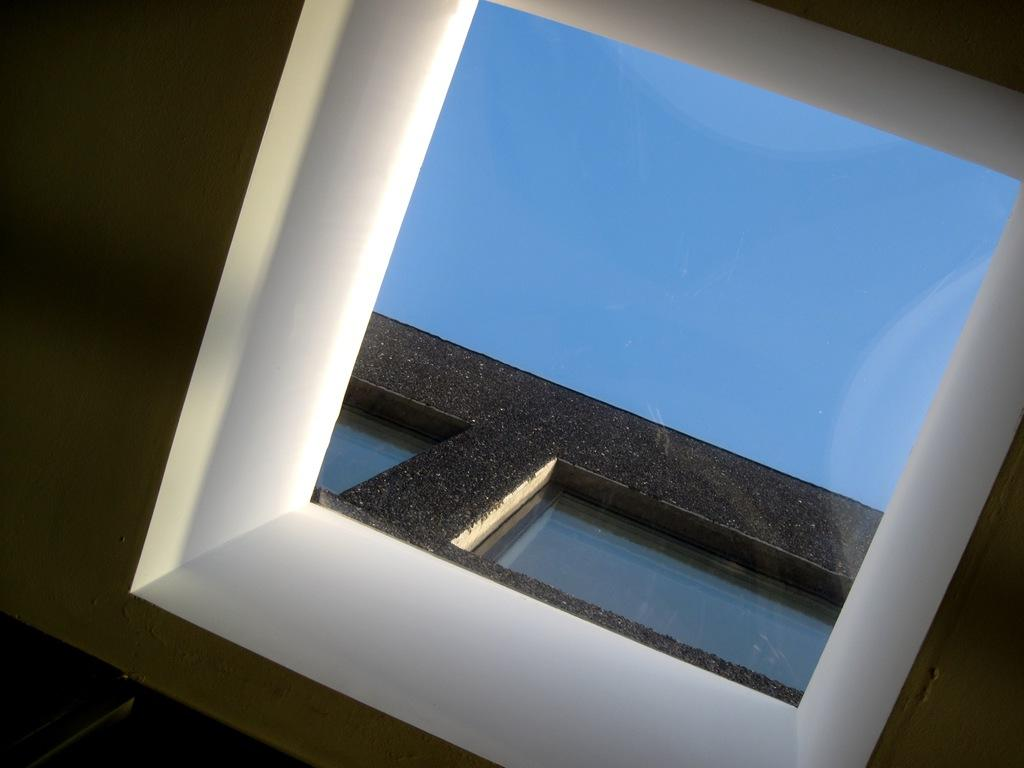What type of structure is visible in the image? There is a glass structure in the image. How high does the glass extend? The glass extends to the ceiling. What can be seen through the glass? The sky is visible through the glass. Where is the stove located in the image? There is no stove present in the image. Can you see a lake through the glass structure? There is no lake visible through the glass structure in the image. 